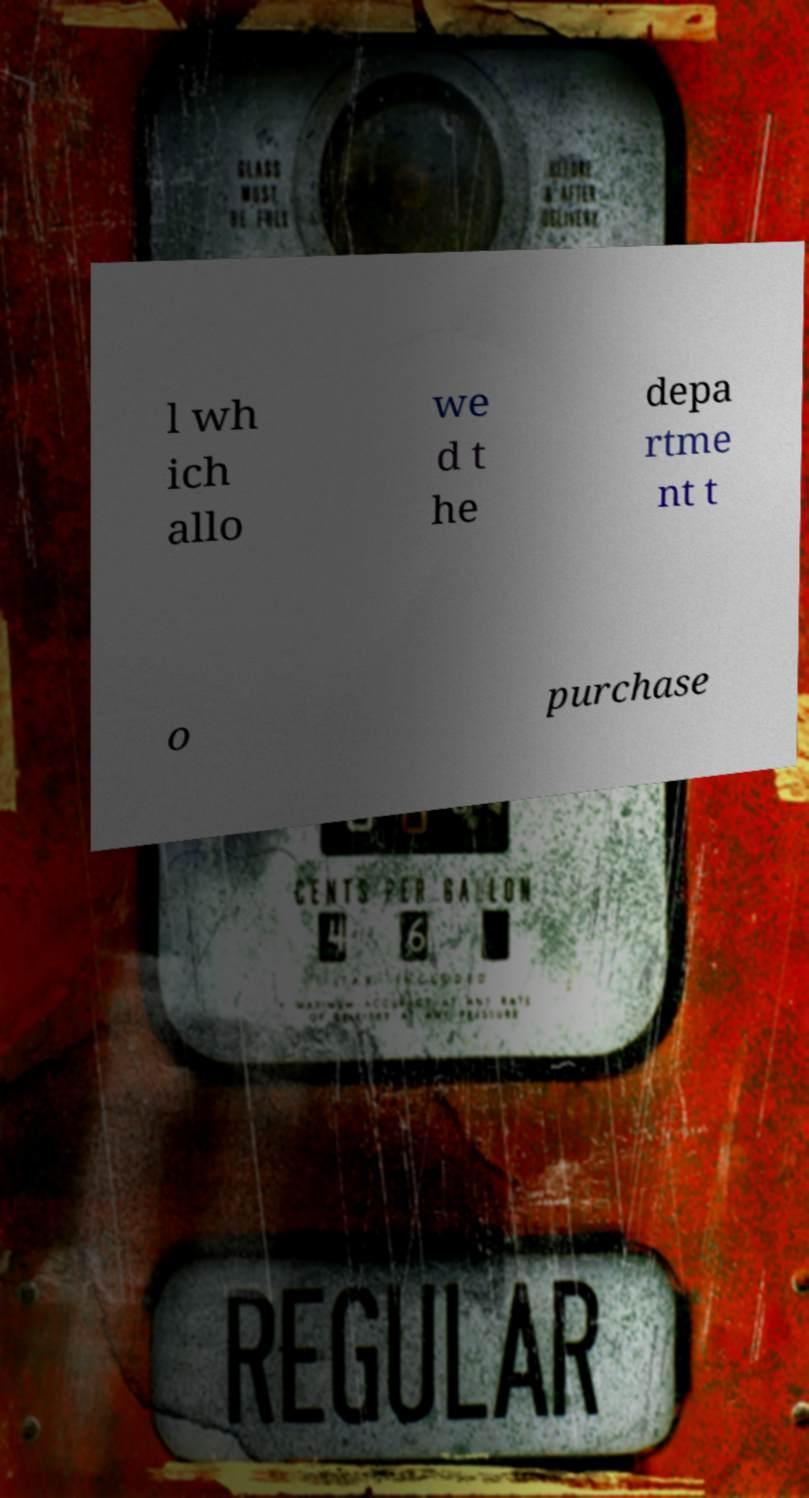What messages or text are displayed in this image? I need them in a readable, typed format. l wh ich allo we d t he depa rtme nt t o purchase 